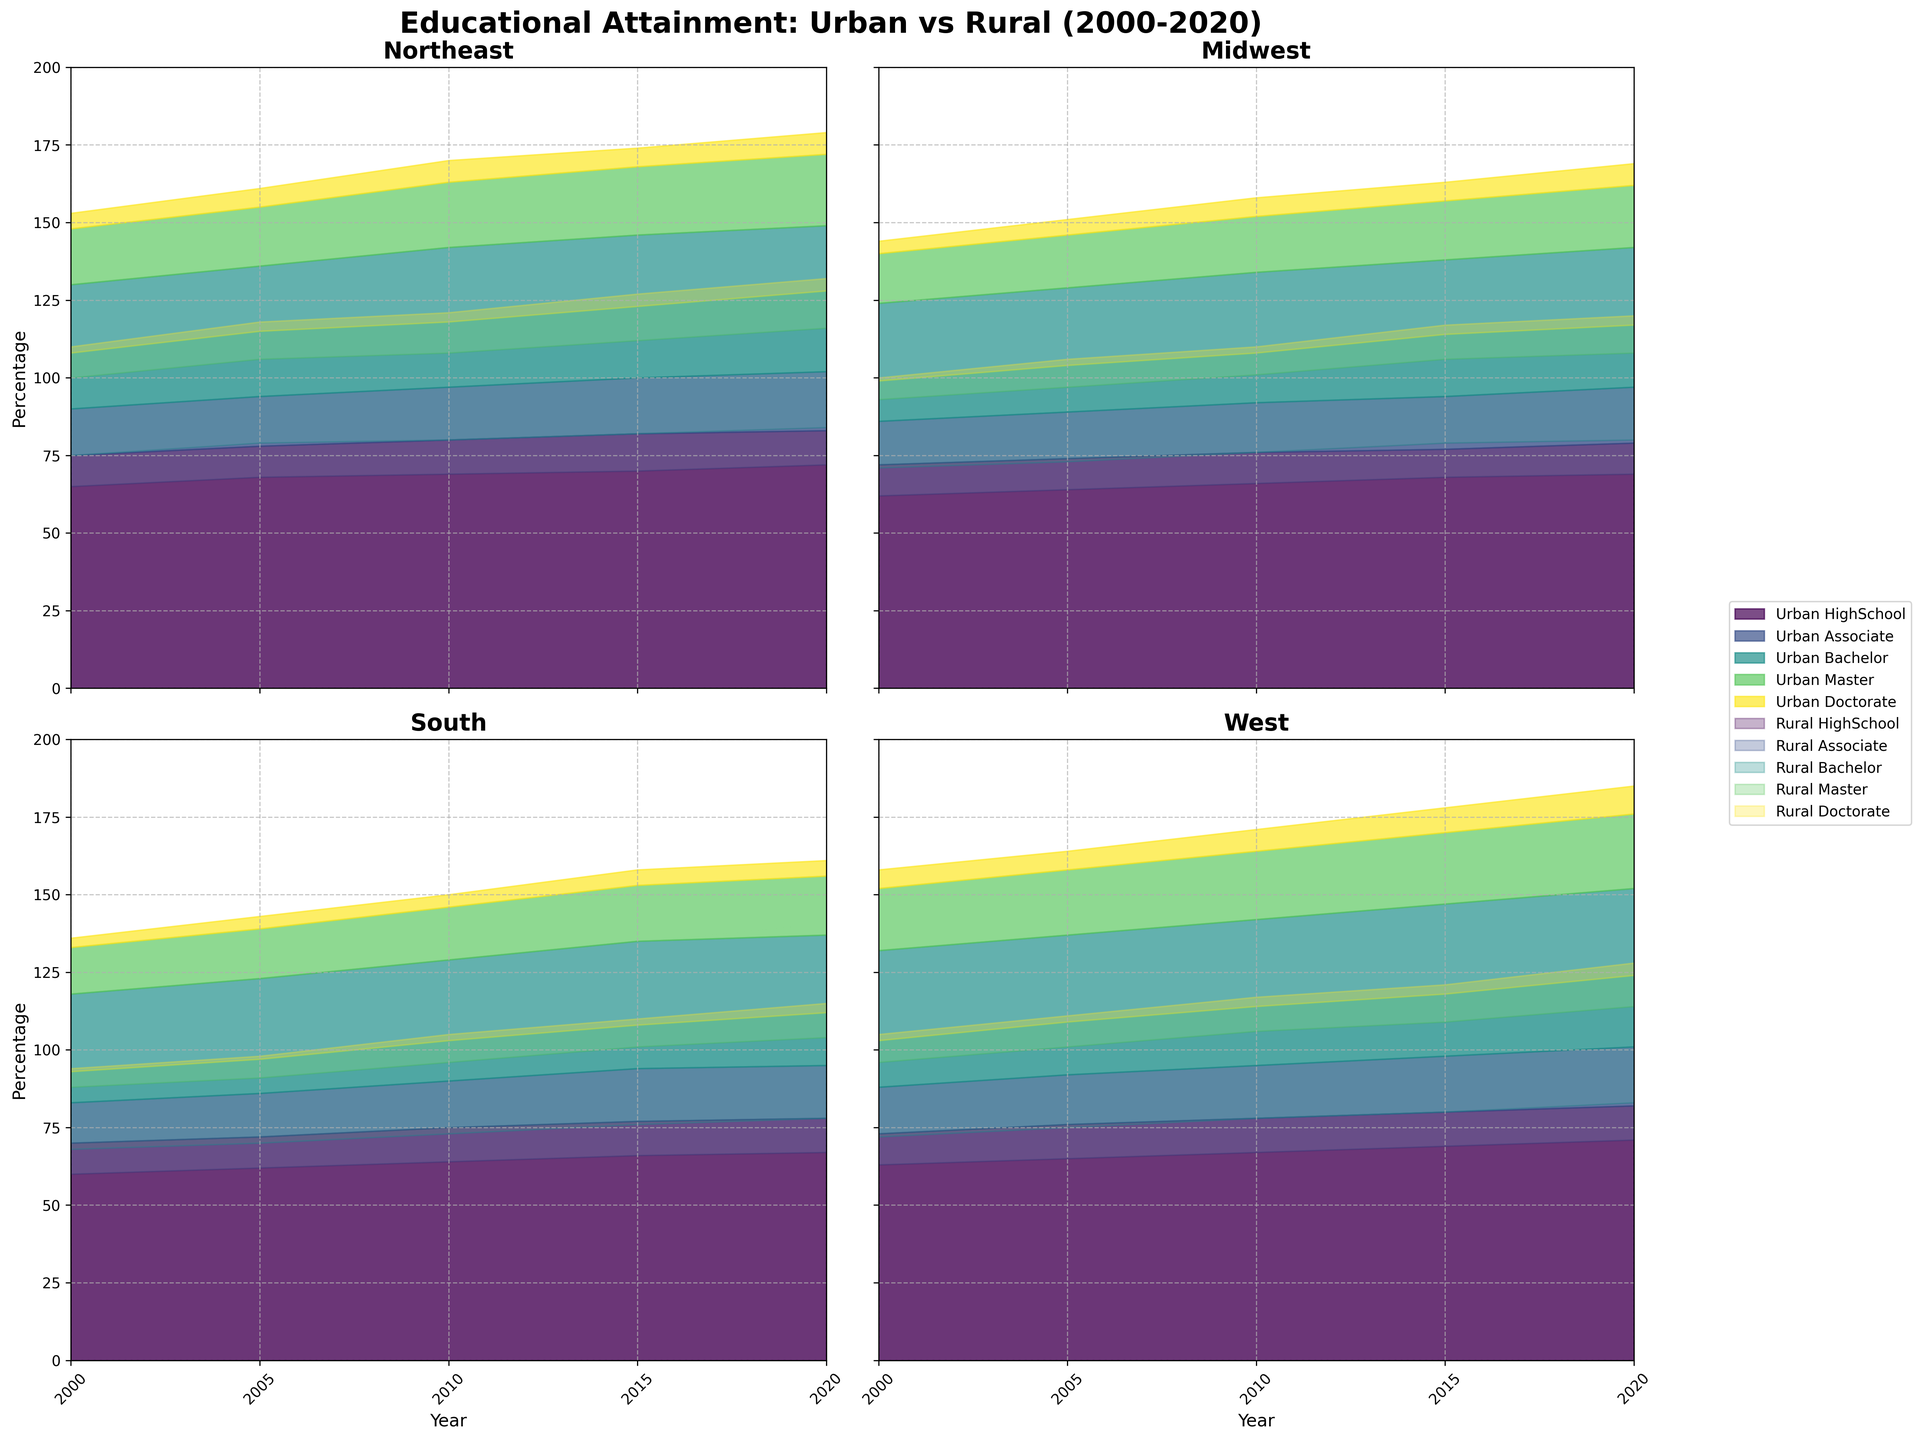What is the title of the entire figure? The title of the entire figure is prominently placed above the subplots and summarizes the theme of the chart. The title reads "Educational Attainment: Urban vs Rural (2000-2020)".
Answer: Educational Attainment: Urban vs Rural (2000-2020) Which region shows the highest percentage of people with Bachelor degrees in 2020 for urban areas? The Western region's urban subplot indicates the highest percentage for Bachelor degrees in 2020, highlighted prominently on the rightmost portion of the area chart.
Answer: West How has the percentage of high school attainment changed for rural areas in the Midwest from 2000 to 2020? In the Midwest's rural area subplot, looking at the 'HighSchool' section, the percentage starts at 62 in 2000 and increases to 69 in 2020. The trend shows a gradual increase over time.
Answer: Increased from 62 to 69 Between the Northeast and the South, which urban area had a higher percentage of people with a Master’s degree in 2015? By comparing the urban subplots for both the Northeast and the South in 2015, the higher area for 'Master' attainment appears in the Northeast, indicated by a taller section of the chart.
Answer: Northeast What is the sum of percentages for all educational levels in the rural West in 2010? Summing the educational levels in the rural West area subplot for 2010: HighSchool (67) + Associate (11) + Bachelor (28) + Master (8) + Doctorate (3) = 117.
Answer: 117 In which year did the Midwest urban area reach a 17% attainment in Associate degrees? The 2015 section in the Midwest urban area subplot shows the 'Associate' level first reaching 17%, indicated by the specific color filling up to that value.
Answer: 2015 Compare the change in percentage of Doctorate degrees between urban and rural areas in the South from 2000 to 2020. Which area had a bigger increase? The urban South shows an increase from 3 to 5, while rural South shows an increase from 1 to 3. Urban area increased by 2 points and rural area also increased by 2 points. Hence, both had the same incremental change.
Answer: Both had the same increase What is the general trend of educational attainment for urban areas across all regions from 2000 to 2020? Across all urban subplots, the general trend shows a consistent increase in all educational levels, reflecting a positive growth in educational attainment over the years.
Answer: Consistent increase In 2020, which rural area had the lowest percentage of people with Associate degrees? By comparing the 'Associate' sections across all rural subplots for 2020, the rural South had the lowest percentage marked by the small dominated area in the figure.
Answer: South 